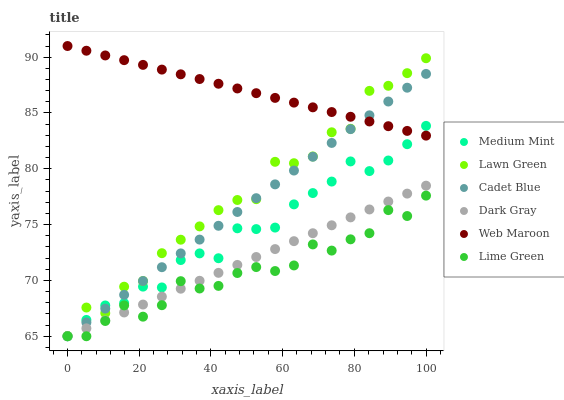Does Lime Green have the minimum area under the curve?
Answer yes or no. Yes. Does Web Maroon have the maximum area under the curve?
Answer yes or no. Yes. Does Lawn Green have the minimum area under the curve?
Answer yes or no. No. Does Lawn Green have the maximum area under the curve?
Answer yes or no. No. Is Web Maroon the smoothest?
Answer yes or no. Yes. Is Lawn Green the roughest?
Answer yes or no. Yes. Is Cadet Blue the smoothest?
Answer yes or no. No. Is Cadet Blue the roughest?
Answer yes or no. No. Does Medium Mint have the lowest value?
Answer yes or no. Yes. Does Lawn Green have the lowest value?
Answer yes or no. No. Does Web Maroon have the highest value?
Answer yes or no. Yes. Does Lawn Green have the highest value?
Answer yes or no. No. Is Lime Green less than Web Maroon?
Answer yes or no. Yes. Is Web Maroon greater than Lime Green?
Answer yes or no. Yes. Does Cadet Blue intersect Dark Gray?
Answer yes or no. Yes. Is Cadet Blue less than Dark Gray?
Answer yes or no. No. Is Cadet Blue greater than Dark Gray?
Answer yes or no. No. Does Lime Green intersect Web Maroon?
Answer yes or no. No. 